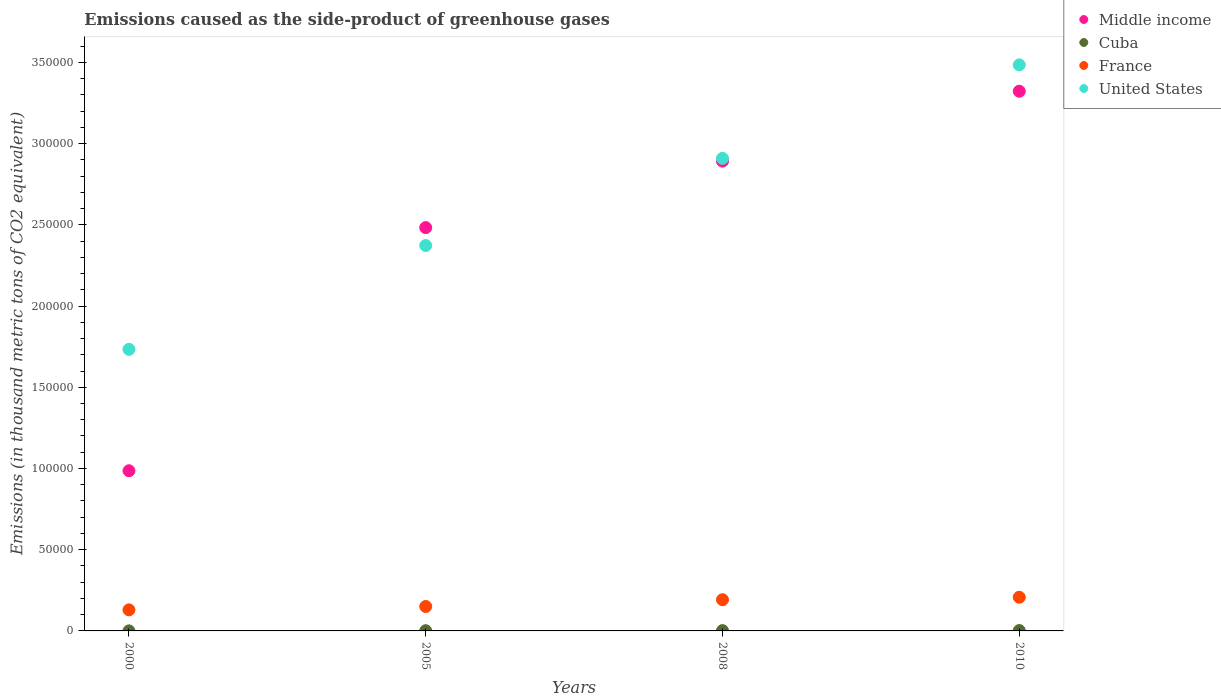How many different coloured dotlines are there?
Your answer should be very brief. 4. Is the number of dotlines equal to the number of legend labels?
Your answer should be compact. Yes. What is the emissions caused as the side-product of greenhouse gases in Cuba in 2000?
Provide a succinct answer. 34.2. Across all years, what is the maximum emissions caused as the side-product of greenhouse gases in United States?
Ensure brevity in your answer.  3.48e+05. Across all years, what is the minimum emissions caused as the side-product of greenhouse gases in France?
Your answer should be compact. 1.30e+04. In which year was the emissions caused as the side-product of greenhouse gases in Cuba maximum?
Provide a succinct answer. 2010. What is the total emissions caused as the side-product of greenhouse gases in Cuba in the graph?
Offer a very short reply. 573.9. What is the difference between the emissions caused as the side-product of greenhouse gases in France in 2008 and that in 2010?
Ensure brevity in your answer.  -1528. What is the difference between the emissions caused as the side-product of greenhouse gases in United States in 2010 and the emissions caused as the side-product of greenhouse gases in Middle income in 2008?
Your response must be concise. 5.92e+04. What is the average emissions caused as the side-product of greenhouse gases in Cuba per year?
Keep it short and to the point. 143.47. In the year 2005, what is the difference between the emissions caused as the side-product of greenhouse gases in Cuba and emissions caused as the side-product of greenhouse gases in France?
Offer a terse response. -1.49e+04. In how many years, is the emissions caused as the side-product of greenhouse gases in France greater than 110000 thousand metric tons?
Ensure brevity in your answer.  0. What is the ratio of the emissions caused as the side-product of greenhouse gases in France in 2005 to that in 2010?
Provide a short and direct response. 0.73. What is the difference between the highest and the second highest emissions caused as the side-product of greenhouse gases in Cuba?
Offer a terse response. 40.1. What is the difference between the highest and the lowest emissions caused as the side-product of greenhouse gases in Middle income?
Give a very brief answer. 2.34e+05. In how many years, is the emissions caused as the side-product of greenhouse gases in Middle income greater than the average emissions caused as the side-product of greenhouse gases in Middle income taken over all years?
Your answer should be very brief. 3. Is it the case that in every year, the sum of the emissions caused as the side-product of greenhouse gases in France and emissions caused as the side-product of greenhouse gases in Middle income  is greater than the sum of emissions caused as the side-product of greenhouse gases in United States and emissions caused as the side-product of greenhouse gases in Cuba?
Provide a short and direct response. Yes. Is it the case that in every year, the sum of the emissions caused as the side-product of greenhouse gases in Middle income and emissions caused as the side-product of greenhouse gases in France  is greater than the emissions caused as the side-product of greenhouse gases in United States?
Your response must be concise. No. Does the emissions caused as the side-product of greenhouse gases in Middle income monotonically increase over the years?
Provide a short and direct response. Yes. Is the emissions caused as the side-product of greenhouse gases in Cuba strictly less than the emissions caused as the side-product of greenhouse gases in Middle income over the years?
Your answer should be very brief. Yes. Are the values on the major ticks of Y-axis written in scientific E-notation?
Your response must be concise. No. Does the graph contain any zero values?
Provide a short and direct response. No. How many legend labels are there?
Give a very brief answer. 4. What is the title of the graph?
Give a very brief answer. Emissions caused as the side-product of greenhouse gases. What is the label or title of the Y-axis?
Offer a very short reply. Emissions (in thousand metric tons of CO2 equivalent). What is the Emissions (in thousand metric tons of CO2 equivalent) of Middle income in 2000?
Offer a terse response. 9.86e+04. What is the Emissions (in thousand metric tons of CO2 equivalent) of Cuba in 2000?
Give a very brief answer. 34.2. What is the Emissions (in thousand metric tons of CO2 equivalent) in France in 2000?
Offer a very short reply. 1.30e+04. What is the Emissions (in thousand metric tons of CO2 equivalent) of United States in 2000?
Your answer should be very brief. 1.73e+05. What is the Emissions (in thousand metric tons of CO2 equivalent) in Middle income in 2005?
Your answer should be compact. 2.48e+05. What is the Emissions (in thousand metric tons of CO2 equivalent) in Cuba in 2005?
Give a very brief answer. 127.8. What is the Emissions (in thousand metric tons of CO2 equivalent) in France in 2005?
Offer a terse response. 1.50e+04. What is the Emissions (in thousand metric tons of CO2 equivalent) in United States in 2005?
Your response must be concise. 2.37e+05. What is the Emissions (in thousand metric tons of CO2 equivalent) in Middle income in 2008?
Offer a terse response. 2.89e+05. What is the Emissions (in thousand metric tons of CO2 equivalent) of Cuba in 2008?
Provide a short and direct response. 185.9. What is the Emissions (in thousand metric tons of CO2 equivalent) in France in 2008?
Keep it short and to the point. 1.92e+04. What is the Emissions (in thousand metric tons of CO2 equivalent) in United States in 2008?
Make the answer very short. 2.91e+05. What is the Emissions (in thousand metric tons of CO2 equivalent) of Middle income in 2010?
Your answer should be very brief. 3.32e+05. What is the Emissions (in thousand metric tons of CO2 equivalent) in Cuba in 2010?
Your answer should be compact. 226. What is the Emissions (in thousand metric tons of CO2 equivalent) in France in 2010?
Your answer should be compact. 2.07e+04. What is the Emissions (in thousand metric tons of CO2 equivalent) in United States in 2010?
Ensure brevity in your answer.  3.48e+05. Across all years, what is the maximum Emissions (in thousand metric tons of CO2 equivalent) in Middle income?
Ensure brevity in your answer.  3.32e+05. Across all years, what is the maximum Emissions (in thousand metric tons of CO2 equivalent) of Cuba?
Ensure brevity in your answer.  226. Across all years, what is the maximum Emissions (in thousand metric tons of CO2 equivalent) in France?
Your response must be concise. 2.07e+04. Across all years, what is the maximum Emissions (in thousand metric tons of CO2 equivalent) of United States?
Keep it short and to the point. 3.48e+05. Across all years, what is the minimum Emissions (in thousand metric tons of CO2 equivalent) in Middle income?
Offer a terse response. 9.86e+04. Across all years, what is the minimum Emissions (in thousand metric tons of CO2 equivalent) in Cuba?
Provide a succinct answer. 34.2. Across all years, what is the minimum Emissions (in thousand metric tons of CO2 equivalent) in France?
Keep it short and to the point. 1.30e+04. Across all years, what is the minimum Emissions (in thousand metric tons of CO2 equivalent) in United States?
Keep it short and to the point. 1.73e+05. What is the total Emissions (in thousand metric tons of CO2 equivalent) in Middle income in the graph?
Offer a very short reply. 9.68e+05. What is the total Emissions (in thousand metric tons of CO2 equivalent) of Cuba in the graph?
Give a very brief answer. 573.9. What is the total Emissions (in thousand metric tons of CO2 equivalent) in France in the graph?
Keep it short and to the point. 6.79e+04. What is the total Emissions (in thousand metric tons of CO2 equivalent) in United States in the graph?
Offer a very short reply. 1.05e+06. What is the difference between the Emissions (in thousand metric tons of CO2 equivalent) in Middle income in 2000 and that in 2005?
Ensure brevity in your answer.  -1.50e+05. What is the difference between the Emissions (in thousand metric tons of CO2 equivalent) in Cuba in 2000 and that in 2005?
Provide a short and direct response. -93.6. What is the difference between the Emissions (in thousand metric tons of CO2 equivalent) of France in 2000 and that in 2005?
Provide a short and direct response. -2068. What is the difference between the Emissions (in thousand metric tons of CO2 equivalent) of United States in 2000 and that in 2005?
Offer a terse response. -6.39e+04. What is the difference between the Emissions (in thousand metric tons of CO2 equivalent) in Middle income in 2000 and that in 2008?
Your response must be concise. -1.91e+05. What is the difference between the Emissions (in thousand metric tons of CO2 equivalent) of Cuba in 2000 and that in 2008?
Your answer should be compact. -151.7. What is the difference between the Emissions (in thousand metric tons of CO2 equivalent) of France in 2000 and that in 2008?
Your response must be concise. -6233.8. What is the difference between the Emissions (in thousand metric tons of CO2 equivalent) in United States in 2000 and that in 2008?
Make the answer very short. -1.18e+05. What is the difference between the Emissions (in thousand metric tons of CO2 equivalent) in Middle income in 2000 and that in 2010?
Give a very brief answer. -2.34e+05. What is the difference between the Emissions (in thousand metric tons of CO2 equivalent) in Cuba in 2000 and that in 2010?
Give a very brief answer. -191.8. What is the difference between the Emissions (in thousand metric tons of CO2 equivalent) in France in 2000 and that in 2010?
Offer a terse response. -7761.8. What is the difference between the Emissions (in thousand metric tons of CO2 equivalent) in United States in 2000 and that in 2010?
Your answer should be compact. -1.75e+05. What is the difference between the Emissions (in thousand metric tons of CO2 equivalent) in Middle income in 2005 and that in 2008?
Your answer should be compact. -4.09e+04. What is the difference between the Emissions (in thousand metric tons of CO2 equivalent) of Cuba in 2005 and that in 2008?
Your answer should be very brief. -58.1. What is the difference between the Emissions (in thousand metric tons of CO2 equivalent) of France in 2005 and that in 2008?
Offer a terse response. -4165.8. What is the difference between the Emissions (in thousand metric tons of CO2 equivalent) of United States in 2005 and that in 2008?
Provide a short and direct response. -5.37e+04. What is the difference between the Emissions (in thousand metric tons of CO2 equivalent) in Middle income in 2005 and that in 2010?
Offer a terse response. -8.40e+04. What is the difference between the Emissions (in thousand metric tons of CO2 equivalent) in Cuba in 2005 and that in 2010?
Your answer should be compact. -98.2. What is the difference between the Emissions (in thousand metric tons of CO2 equivalent) of France in 2005 and that in 2010?
Keep it short and to the point. -5693.8. What is the difference between the Emissions (in thousand metric tons of CO2 equivalent) of United States in 2005 and that in 2010?
Ensure brevity in your answer.  -1.11e+05. What is the difference between the Emissions (in thousand metric tons of CO2 equivalent) of Middle income in 2008 and that in 2010?
Your response must be concise. -4.30e+04. What is the difference between the Emissions (in thousand metric tons of CO2 equivalent) in Cuba in 2008 and that in 2010?
Your answer should be very brief. -40.1. What is the difference between the Emissions (in thousand metric tons of CO2 equivalent) in France in 2008 and that in 2010?
Offer a terse response. -1528. What is the difference between the Emissions (in thousand metric tons of CO2 equivalent) in United States in 2008 and that in 2010?
Your answer should be compact. -5.75e+04. What is the difference between the Emissions (in thousand metric tons of CO2 equivalent) in Middle income in 2000 and the Emissions (in thousand metric tons of CO2 equivalent) in Cuba in 2005?
Your answer should be compact. 9.85e+04. What is the difference between the Emissions (in thousand metric tons of CO2 equivalent) in Middle income in 2000 and the Emissions (in thousand metric tons of CO2 equivalent) in France in 2005?
Make the answer very short. 8.36e+04. What is the difference between the Emissions (in thousand metric tons of CO2 equivalent) of Middle income in 2000 and the Emissions (in thousand metric tons of CO2 equivalent) of United States in 2005?
Provide a short and direct response. -1.39e+05. What is the difference between the Emissions (in thousand metric tons of CO2 equivalent) of Cuba in 2000 and the Emissions (in thousand metric tons of CO2 equivalent) of France in 2005?
Your answer should be compact. -1.50e+04. What is the difference between the Emissions (in thousand metric tons of CO2 equivalent) of Cuba in 2000 and the Emissions (in thousand metric tons of CO2 equivalent) of United States in 2005?
Your answer should be compact. -2.37e+05. What is the difference between the Emissions (in thousand metric tons of CO2 equivalent) in France in 2000 and the Emissions (in thousand metric tons of CO2 equivalent) in United States in 2005?
Keep it short and to the point. -2.24e+05. What is the difference between the Emissions (in thousand metric tons of CO2 equivalent) in Middle income in 2000 and the Emissions (in thousand metric tons of CO2 equivalent) in Cuba in 2008?
Ensure brevity in your answer.  9.84e+04. What is the difference between the Emissions (in thousand metric tons of CO2 equivalent) of Middle income in 2000 and the Emissions (in thousand metric tons of CO2 equivalent) of France in 2008?
Give a very brief answer. 7.94e+04. What is the difference between the Emissions (in thousand metric tons of CO2 equivalent) of Middle income in 2000 and the Emissions (in thousand metric tons of CO2 equivalent) of United States in 2008?
Provide a succinct answer. -1.92e+05. What is the difference between the Emissions (in thousand metric tons of CO2 equivalent) in Cuba in 2000 and the Emissions (in thousand metric tons of CO2 equivalent) in France in 2008?
Your answer should be compact. -1.92e+04. What is the difference between the Emissions (in thousand metric tons of CO2 equivalent) of Cuba in 2000 and the Emissions (in thousand metric tons of CO2 equivalent) of United States in 2008?
Your answer should be very brief. -2.91e+05. What is the difference between the Emissions (in thousand metric tons of CO2 equivalent) of France in 2000 and the Emissions (in thousand metric tons of CO2 equivalent) of United States in 2008?
Your answer should be very brief. -2.78e+05. What is the difference between the Emissions (in thousand metric tons of CO2 equivalent) in Middle income in 2000 and the Emissions (in thousand metric tons of CO2 equivalent) in Cuba in 2010?
Give a very brief answer. 9.84e+04. What is the difference between the Emissions (in thousand metric tons of CO2 equivalent) in Middle income in 2000 and the Emissions (in thousand metric tons of CO2 equivalent) in France in 2010?
Offer a terse response. 7.79e+04. What is the difference between the Emissions (in thousand metric tons of CO2 equivalent) in Middle income in 2000 and the Emissions (in thousand metric tons of CO2 equivalent) in United States in 2010?
Make the answer very short. -2.50e+05. What is the difference between the Emissions (in thousand metric tons of CO2 equivalent) in Cuba in 2000 and the Emissions (in thousand metric tons of CO2 equivalent) in France in 2010?
Offer a very short reply. -2.07e+04. What is the difference between the Emissions (in thousand metric tons of CO2 equivalent) in Cuba in 2000 and the Emissions (in thousand metric tons of CO2 equivalent) in United States in 2010?
Make the answer very short. -3.48e+05. What is the difference between the Emissions (in thousand metric tons of CO2 equivalent) in France in 2000 and the Emissions (in thousand metric tons of CO2 equivalent) in United States in 2010?
Provide a short and direct response. -3.35e+05. What is the difference between the Emissions (in thousand metric tons of CO2 equivalent) in Middle income in 2005 and the Emissions (in thousand metric tons of CO2 equivalent) in Cuba in 2008?
Keep it short and to the point. 2.48e+05. What is the difference between the Emissions (in thousand metric tons of CO2 equivalent) in Middle income in 2005 and the Emissions (in thousand metric tons of CO2 equivalent) in France in 2008?
Ensure brevity in your answer.  2.29e+05. What is the difference between the Emissions (in thousand metric tons of CO2 equivalent) in Middle income in 2005 and the Emissions (in thousand metric tons of CO2 equivalent) in United States in 2008?
Offer a terse response. -4.26e+04. What is the difference between the Emissions (in thousand metric tons of CO2 equivalent) of Cuba in 2005 and the Emissions (in thousand metric tons of CO2 equivalent) of France in 2008?
Give a very brief answer. -1.91e+04. What is the difference between the Emissions (in thousand metric tons of CO2 equivalent) of Cuba in 2005 and the Emissions (in thousand metric tons of CO2 equivalent) of United States in 2008?
Your response must be concise. -2.91e+05. What is the difference between the Emissions (in thousand metric tons of CO2 equivalent) in France in 2005 and the Emissions (in thousand metric tons of CO2 equivalent) in United States in 2008?
Make the answer very short. -2.76e+05. What is the difference between the Emissions (in thousand metric tons of CO2 equivalent) in Middle income in 2005 and the Emissions (in thousand metric tons of CO2 equivalent) in Cuba in 2010?
Keep it short and to the point. 2.48e+05. What is the difference between the Emissions (in thousand metric tons of CO2 equivalent) in Middle income in 2005 and the Emissions (in thousand metric tons of CO2 equivalent) in France in 2010?
Make the answer very short. 2.28e+05. What is the difference between the Emissions (in thousand metric tons of CO2 equivalent) in Middle income in 2005 and the Emissions (in thousand metric tons of CO2 equivalent) in United States in 2010?
Provide a short and direct response. -1.00e+05. What is the difference between the Emissions (in thousand metric tons of CO2 equivalent) in Cuba in 2005 and the Emissions (in thousand metric tons of CO2 equivalent) in France in 2010?
Your response must be concise. -2.06e+04. What is the difference between the Emissions (in thousand metric tons of CO2 equivalent) in Cuba in 2005 and the Emissions (in thousand metric tons of CO2 equivalent) in United States in 2010?
Make the answer very short. -3.48e+05. What is the difference between the Emissions (in thousand metric tons of CO2 equivalent) in France in 2005 and the Emissions (in thousand metric tons of CO2 equivalent) in United States in 2010?
Keep it short and to the point. -3.33e+05. What is the difference between the Emissions (in thousand metric tons of CO2 equivalent) of Middle income in 2008 and the Emissions (in thousand metric tons of CO2 equivalent) of Cuba in 2010?
Keep it short and to the point. 2.89e+05. What is the difference between the Emissions (in thousand metric tons of CO2 equivalent) in Middle income in 2008 and the Emissions (in thousand metric tons of CO2 equivalent) in France in 2010?
Keep it short and to the point. 2.68e+05. What is the difference between the Emissions (in thousand metric tons of CO2 equivalent) of Middle income in 2008 and the Emissions (in thousand metric tons of CO2 equivalent) of United States in 2010?
Your response must be concise. -5.92e+04. What is the difference between the Emissions (in thousand metric tons of CO2 equivalent) of Cuba in 2008 and the Emissions (in thousand metric tons of CO2 equivalent) of France in 2010?
Offer a very short reply. -2.05e+04. What is the difference between the Emissions (in thousand metric tons of CO2 equivalent) of Cuba in 2008 and the Emissions (in thousand metric tons of CO2 equivalent) of United States in 2010?
Your answer should be compact. -3.48e+05. What is the difference between the Emissions (in thousand metric tons of CO2 equivalent) of France in 2008 and the Emissions (in thousand metric tons of CO2 equivalent) of United States in 2010?
Your answer should be compact. -3.29e+05. What is the average Emissions (in thousand metric tons of CO2 equivalent) in Middle income per year?
Provide a succinct answer. 2.42e+05. What is the average Emissions (in thousand metric tons of CO2 equivalent) in Cuba per year?
Ensure brevity in your answer.  143.47. What is the average Emissions (in thousand metric tons of CO2 equivalent) of France per year?
Your answer should be compact. 1.70e+04. What is the average Emissions (in thousand metric tons of CO2 equivalent) in United States per year?
Ensure brevity in your answer.  2.62e+05. In the year 2000, what is the difference between the Emissions (in thousand metric tons of CO2 equivalent) in Middle income and Emissions (in thousand metric tons of CO2 equivalent) in Cuba?
Make the answer very short. 9.86e+04. In the year 2000, what is the difference between the Emissions (in thousand metric tons of CO2 equivalent) in Middle income and Emissions (in thousand metric tons of CO2 equivalent) in France?
Keep it short and to the point. 8.56e+04. In the year 2000, what is the difference between the Emissions (in thousand metric tons of CO2 equivalent) of Middle income and Emissions (in thousand metric tons of CO2 equivalent) of United States?
Your answer should be compact. -7.47e+04. In the year 2000, what is the difference between the Emissions (in thousand metric tons of CO2 equivalent) in Cuba and Emissions (in thousand metric tons of CO2 equivalent) in France?
Provide a succinct answer. -1.29e+04. In the year 2000, what is the difference between the Emissions (in thousand metric tons of CO2 equivalent) of Cuba and Emissions (in thousand metric tons of CO2 equivalent) of United States?
Make the answer very short. -1.73e+05. In the year 2000, what is the difference between the Emissions (in thousand metric tons of CO2 equivalent) in France and Emissions (in thousand metric tons of CO2 equivalent) in United States?
Provide a succinct answer. -1.60e+05. In the year 2005, what is the difference between the Emissions (in thousand metric tons of CO2 equivalent) in Middle income and Emissions (in thousand metric tons of CO2 equivalent) in Cuba?
Make the answer very short. 2.48e+05. In the year 2005, what is the difference between the Emissions (in thousand metric tons of CO2 equivalent) in Middle income and Emissions (in thousand metric tons of CO2 equivalent) in France?
Make the answer very short. 2.33e+05. In the year 2005, what is the difference between the Emissions (in thousand metric tons of CO2 equivalent) of Middle income and Emissions (in thousand metric tons of CO2 equivalent) of United States?
Provide a short and direct response. 1.10e+04. In the year 2005, what is the difference between the Emissions (in thousand metric tons of CO2 equivalent) in Cuba and Emissions (in thousand metric tons of CO2 equivalent) in France?
Offer a very short reply. -1.49e+04. In the year 2005, what is the difference between the Emissions (in thousand metric tons of CO2 equivalent) of Cuba and Emissions (in thousand metric tons of CO2 equivalent) of United States?
Offer a very short reply. -2.37e+05. In the year 2005, what is the difference between the Emissions (in thousand metric tons of CO2 equivalent) of France and Emissions (in thousand metric tons of CO2 equivalent) of United States?
Provide a short and direct response. -2.22e+05. In the year 2008, what is the difference between the Emissions (in thousand metric tons of CO2 equivalent) in Middle income and Emissions (in thousand metric tons of CO2 equivalent) in Cuba?
Make the answer very short. 2.89e+05. In the year 2008, what is the difference between the Emissions (in thousand metric tons of CO2 equivalent) in Middle income and Emissions (in thousand metric tons of CO2 equivalent) in France?
Provide a succinct answer. 2.70e+05. In the year 2008, what is the difference between the Emissions (in thousand metric tons of CO2 equivalent) of Middle income and Emissions (in thousand metric tons of CO2 equivalent) of United States?
Your answer should be very brief. -1699. In the year 2008, what is the difference between the Emissions (in thousand metric tons of CO2 equivalent) in Cuba and Emissions (in thousand metric tons of CO2 equivalent) in France?
Ensure brevity in your answer.  -1.90e+04. In the year 2008, what is the difference between the Emissions (in thousand metric tons of CO2 equivalent) of Cuba and Emissions (in thousand metric tons of CO2 equivalent) of United States?
Offer a very short reply. -2.91e+05. In the year 2008, what is the difference between the Emissions (in thousand metric tons of CO2 equivalent) in France and Emissions (in thousand metric tons of CO2 equivalent) in United States?
Provide a succinct answer. -2.72e+05. In the year 2010, what is the difference between the Emissions (in thousand metric tons of CO2 equivalent) in Middle income and Emissions (in thousand metric tons of CO2 equivalent) in Cuba?
Offer a very short reply. 3.32e+05. In the year 2010, what is the difference between the Emissions (in thousand metric tons of CO2 equivalent) in Middle income and Emissions (in thousand metric tons of CO2 equivalent) in France?
Your answer should be very brief. 3.12e+05. In the year 2010, what is the difference between the Emissions (in thousand metric tons of CO2 equivalent) in Middle income and Emissions (in thousand metric tons of CO2 equivalent) in United States?
Provide a short and direct response. -1.62e+04. In the year 2010, what is the difference between the Emissions (in thousand metric tons of CO2 equivalent) in Cuba and Emissions (in thousand metric tons of CO2 equivalent) in France?
Your answer should be very brief. -2.05e+04. In the year 2010, what is the difference between the Emissions (in thousand metric tons of CO2 equivalent) in Cuba and Emissions (in thousand metric tons of CO2 equivalent) in United States?
Your answer should be compact. -3.48e+05. In the year 2010, what is the difference between the Emissions (in thousand metric tons of CO2 equivalent) in France and Emissions (in thousand metric tons of CO2 equivalent) in United States?
Your answer should be compact. -3.28e+05. What is the ratio of the Emissions (in thousand metric tons of CO2 equivalent) in Middle income in 2000 to that in 2005?
Provide a succinct answer. 0.4. What is the ratio of the Emissions (in thousand metric tons of CO2 equivalent) of Cuba in 2000 to that in 2005?
Give a very brief answer. 0.27. What is the ratio of the Emissions (in thousand metric tons of CO2 equivalent) in France in 2000 to that in 2005?
Give a very brief answer. 0.86. What is the ratio of the Emissions (in thousand metric tons of CO2 equivalent) in United States in 2000 to that in 2005?
Your response must be concise. 0.73. What is the ratio of the Emissions (in thousand metric tons of CO2 equivalent) of Middle income in 2000 to that in 2008?
Your response must be concise. 0.34. What is the ratio of the Emissions (in thousand metric tons of CO2 equivalent) in Cuba in 2000 to that in 2008?
Ensure brevity in your answer.  0.18. What is the ratio of the Emissions (in thousand metric tons of CO2 equivalent) of France in 2000 to that in 2008?
Make the answer very short. 0.68. What is the ratio of the Emissions (in thousand metric tons of CO2 equivalent) of United States in 2000 to that in 2008?
Keep it short and to the point. 0.6. What is the ratio of the Emissions (in thousand metric tons of CO2 equivalent) in Middle income in 2000 to that in 2010?
Your answer should be compact. 0.3. What is the ratio of the Emissions (in thousand metric tons of CO2 equivalent) in Cuba in 2000 to that in 2010?
Give a very brief answer. 0.15. What is the ratio of the Emissions (in thousand metric tons of CO2 equivalent) in France in 2000 to that in 2010?
Your response must be concise. 0.63. What is the ratio of the Emissions (in thousand metric tons of CO2 equivalent) of United States in 2000 to that in 2010?
Provide a short and direct response. 0.5. What is the ratio of the Emissions (in thousand metric tons of CO2 equivalent) of Middle income in 2005 to that in 2008?
Your answer should be compact. 0.86. What is the ratio of the Emissions (in thousand metric tons of CO2 equivalent) of Cuba in 2005 to that in 2008?
Keep it short and to the point. 0.69. What is the ratio of the Emissions (in thousand metric tons of CO2 equivalent) in France in 2005 to that in 2008?
Offer a terse response. 0.78. What is the ratio of the Emissions (in thousand metric tons of CO2 equivalent) in United States in 2005 to that in 2008?
Offer a terse response. 0.82. What is the ratio of the Emissions (in thousand metric tons of CO2 equivalent) of Middle income in 2005 to that in 2010?
Offer a very short reply. 0.75. What is the ratio of the Emissions (in thousand metric tons of CO2 equivalent) in Cuba in 2005 to that in 2010?
Provide a short and direct response. 0.57. What is the ratio of the Emissions (in thousand metric tons of CO2 equivalent) of France in 2005 to that in 2010?
Your answer should be compact. 0.73. What is the ratio of the Emissions (in thousand metric tons of CO2 equivalent) in United States in 2005 to that in 2010?
Offer a terse response. 0.68. What is the ratio of the Emissions (in thousand metric tons of CO2 equivalent) in Middle income in 2008 to that in 2010?
Your answer should be very brief. 0.87. What is the ratio of the Emissions (in thousand metric tons of CO2 equivalent) of Cuba in 2008 to that in 2010?
Offer a very short reply. 0.82. What is the ratio of the Emissions (in thousand metric tons of CO2 equivalent) of France in 2008 to that in 2010?
Provide a succinct answer. 0.93. What is the ratio of the Emissions (in thousand metric tons of CO2 equivalent) in United States in 2008 to that in 2010?
Ensure brevity in your answer.  0.83. What is the difference between the highest and the second highest Emissions (in thousand metric tons of CO2 equivalent) in Middle income?
Give a very brief answer. 4.30e+04. What is the difference between the highest and the second highest Emissions (in thousand metric tons of CO2 equivalent) in Cuba?
Ensure brevity in your answer.  40.1. What is the difference between the highest and the second highest Emissions (in thousand metric tons of CO2 equivalent) in France?
Give a very brief answer. 1528. What is the difference between the highest and the second highest Emissions (in thousand metric tons of CO2 equivalent) of United States?
Your answer should be compact. 5.75e+04. What is the difference between the highest and the lowest Emissions (in thousand metric tons of CO2 equivalent) in Middle income?
Your response must be concise. 2.34e+05. What is the difference between the highest and the lowest Emissions (in thousand metric tons of CO2 equivalent) of Cuba?
Your answer should be compact. 191.8. What is the difference between the highest and the lowest Emissions (in thousand metric tons of CO2 equivalent) of France?
Your answer should be very brief. 7761.8. What is the difference between the highest and the lowest Emissions (in thousand metric tons of CO2 equivalent) in United States?
Your answer should be very brief. 1.75e+05. 